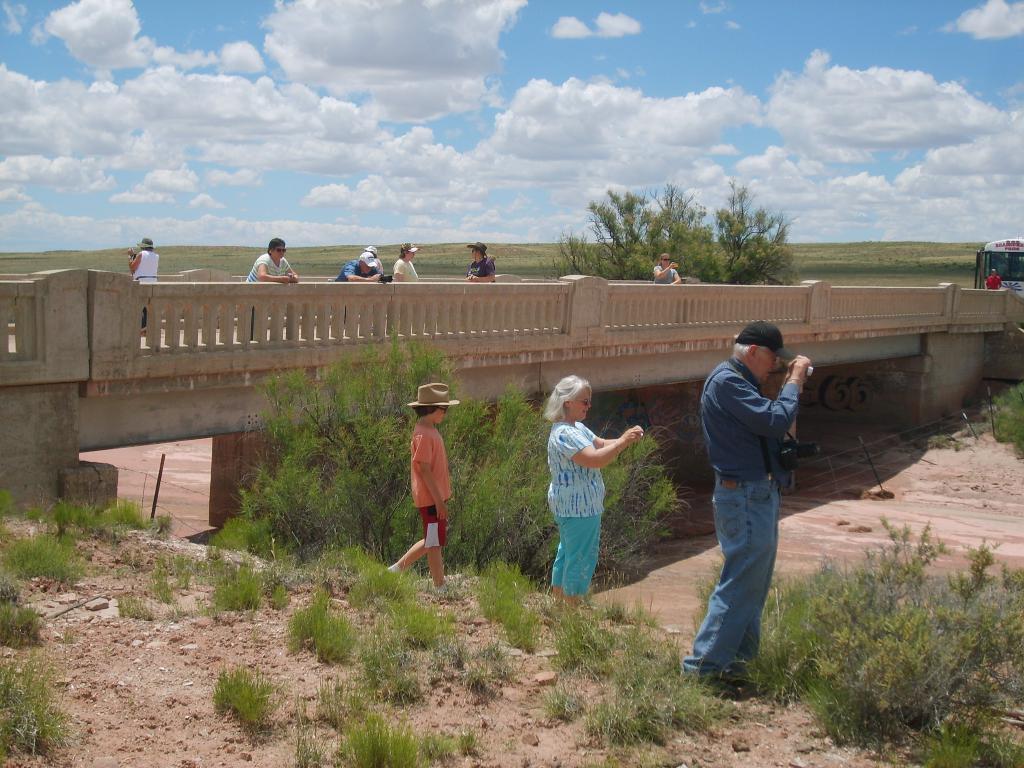In one or two sentences, can you explain what this image depicts? On the right side of the image we can see a man standing and holding a camera in his hand, behind him there is a lady and a boy walking. At the bottom there is grass and bushes. In the background there is a bridge and we can see some people standing on the bridge. There is a vehicle and we can see a sky. 